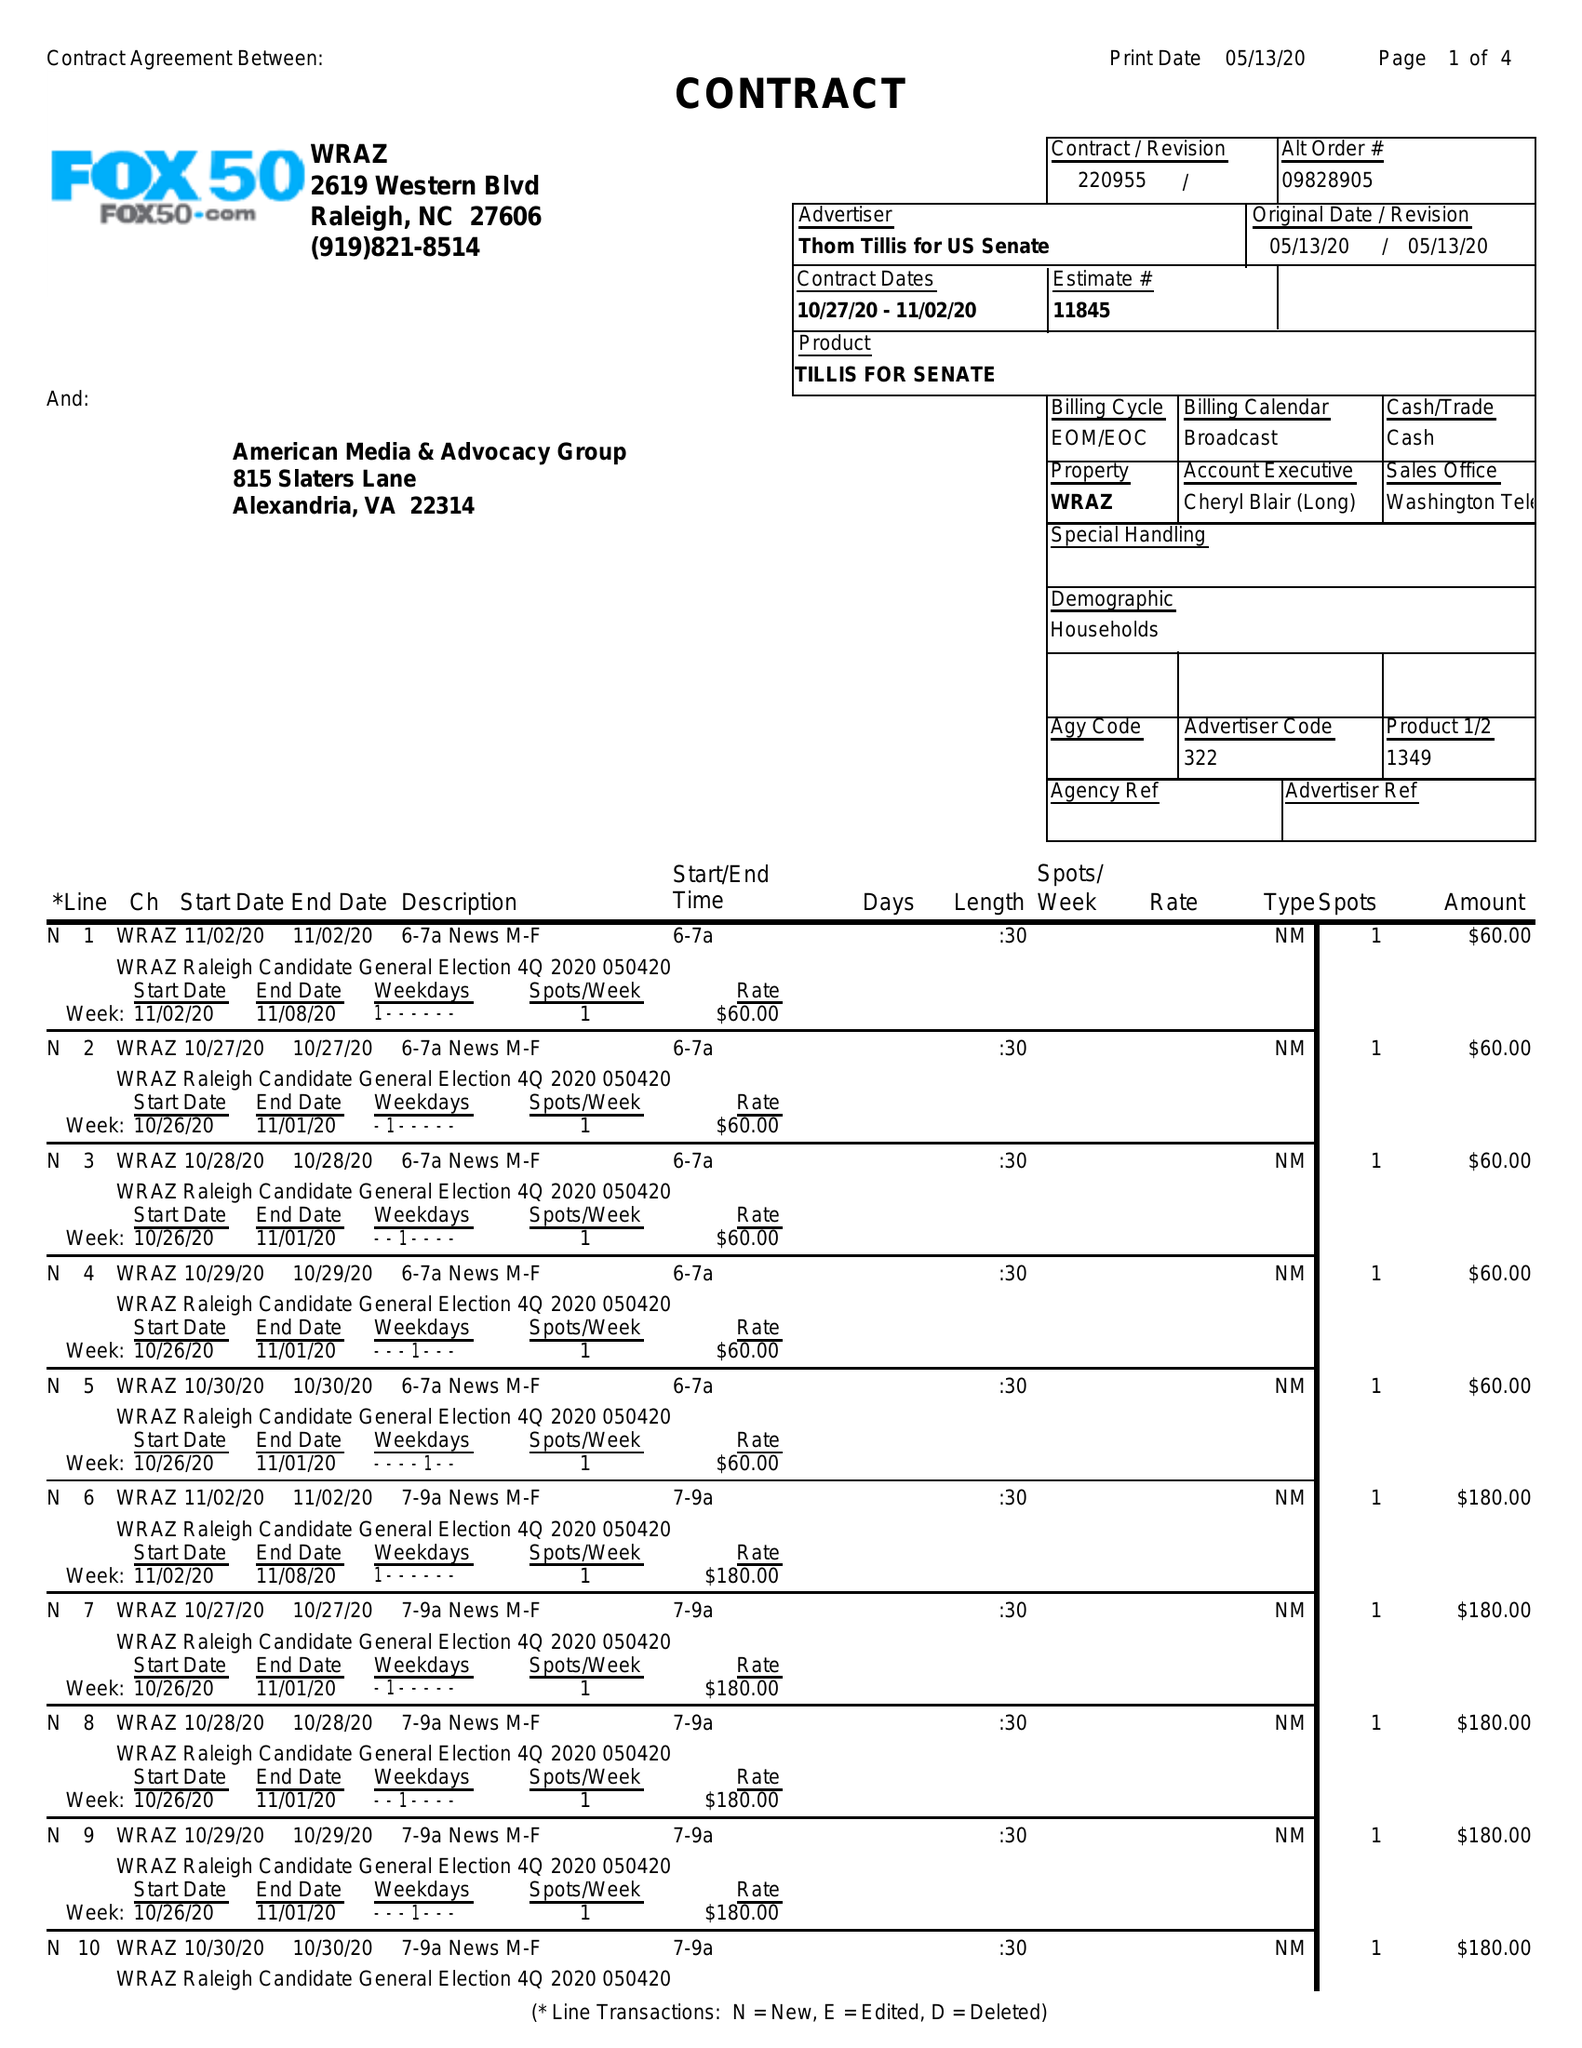What is the value for the gross_amount?
Answer the question using a single word or phrase. 21660.00 